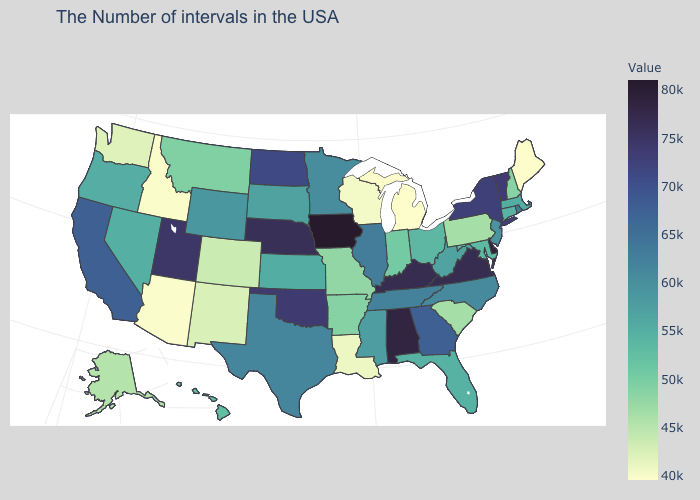Is the legend a continuous bar?
Quick response, please. Yes. Among the states that border Virginia , which have the highest value?
Be succinct. Kentucky. Among the states that border Kansas , which have the lowest value?
Give a very brief answer. Colorado. Among the states that border New Jersey , does Pennsylvania have the highest value?
Keep it brief. No. Does Tennessee have a lower value than Vermont?
Quick response, please. Yes. 